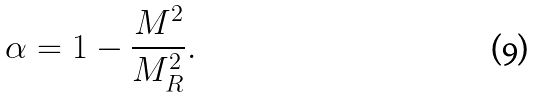<formula> <loc_0><loc_0><loc_500><loc_500>\alpha = 1 - \frac { M ^ { 2 } } { M _ { R } ^ { 2 } } .</formula> 